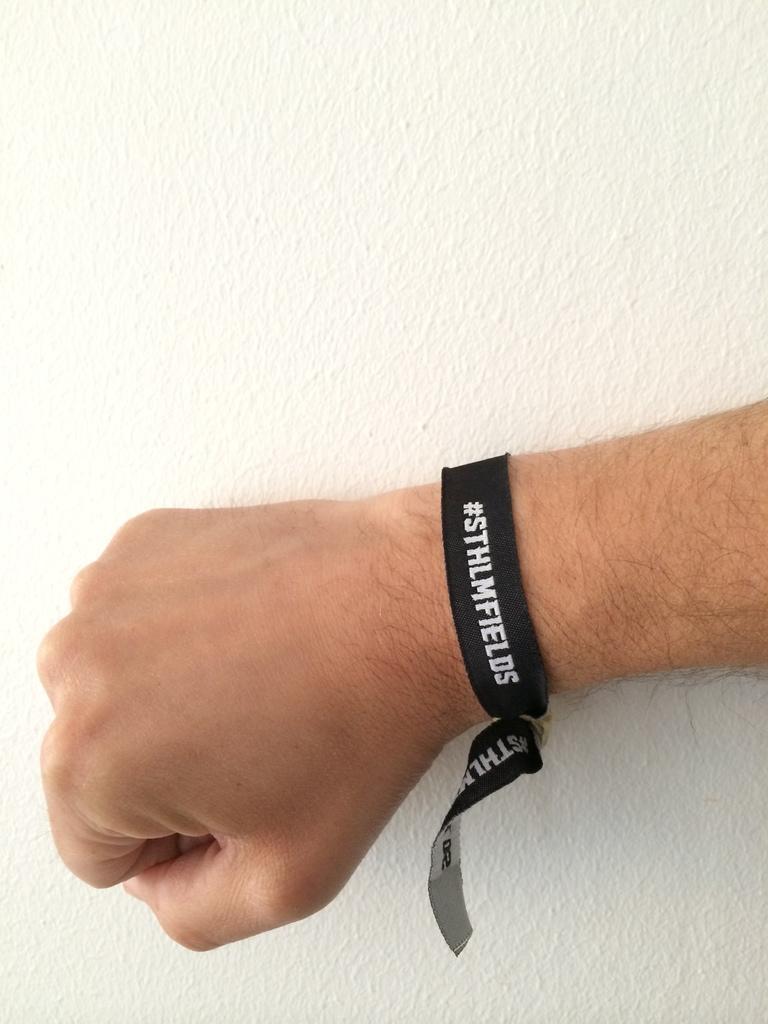Can you describe this image briefly? In this picture we can see a hand of a person wearing a band. 